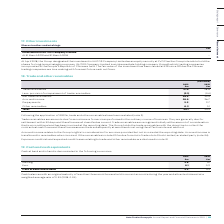According to Auto Trader's financial document, What are trade receivables? amounts due from customers for services performed in the ordinary course of business. The document states: "Trade receivables are amounts due from customers for services performed in the ordinary course of business. They are generally due for settlement with..." Also, What does accrued income relate to? the Group’s rights to consideration for services provided but not invoiced at the reporting date.. The document states: "Accrued income relates to the Group’s rights to consideration for services provided but not invoiced at the reporting date. Accrued income is transfer..." Also, What are the components factored in when calculating the net trade receivables? The document shows two values: Trade receivables and Less: provision for impairment of trade receivables. From the document: "Less: provision for impairment of trade receivables (2.1) (3.4) Less: provision for impairment of trade receivables (2.1) (3.4)..." Also, can you calculate: What was the change in Prepayments in 2019 from 2018? Based on the calculation: 2.9-2.7, the result is 0.2 (in millions). This is based on the information: "Prepayments 2.9 2.7 Prepayments 2.9 2.7..." The key data points involved are: 2.7, 2.9. Also, can you calculate: What was the percentage change in Prepayments in 2019 from 2018? To answer this question, I need to perform calculations using the financial data. The calculation is: (2.9-2.7)/2.7, which equals 7.41 (percentage). This is based on the information: "Prepayments 2.9 2.7 Prepayments 2.9 2.7..." The key data points involved are: 2.7, 2.9. Additionally, In which year was total trade receivables larger? According to the financial document, 2019. The relevant text states: "Group plc Annual Report and Financial Statements 2019 | 111..." 